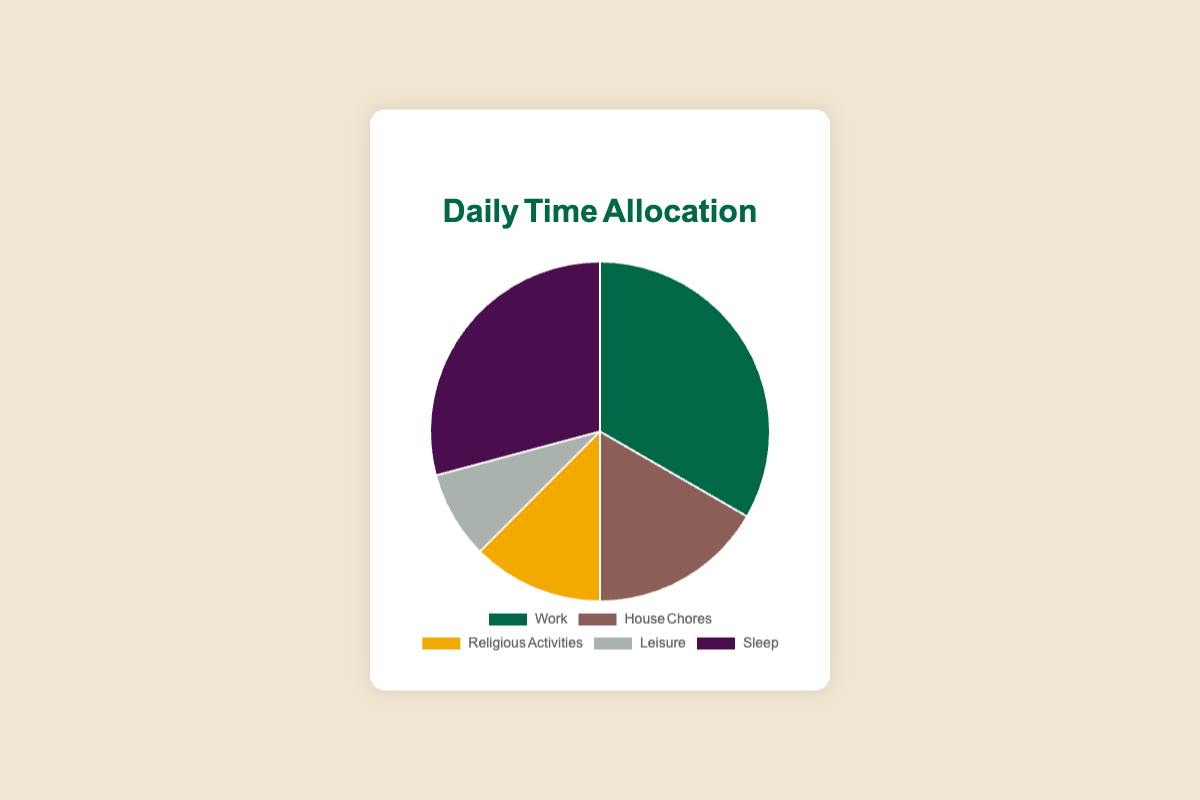What is the total amount of time spent on Work and Sleep combined? The time spent on Work is 8 hours and on Sleep is 7 hours. Adding them together: 8 + 7 = 15.
Answer: 15 hours Which activity has the longest duration? By looking at the pie chart, the activity with the longest duration is "Work" which has 8 hours.
Answer: Work Which activity has more hours allocated: House Chores or Leisure? By comparing the durations, House Chores has 4 hours and Leisure has 2 hours. House Chores has more allocated hours.
Answer: House Chores What is the difference in time allocation between the activity with the most hours and the activity with the least hours? The activity with the most hours is Work (8 hours). The one with the least is Leisure (2 hours). The difference is 8 - 2 = 6.
Answer: 6 hours How many more hours are spent on Religious Activities compared to Leisure? Religious Activities take 3 hours and Leisure takes 2 hours. The difference is 3 - 2 = 1.
Answer: 1 hour What is the total number of hours dedicated to activities other than Sleep? The total time excluding Sleep (7 hours) can be found by adding the hours of all other activities: Work (8) + House Chores (4) + Religious Activities (3) + Leisure (2) = 17.
Answer: 17 hours What percentage of the day is allocated to Religious Activities? The total hours in a day considered here is 24. Religious Activities take 3 hours. The percentage is calculated as (3/24) * 100 ≈ 12.5%.
Answer: ~12.5% How does the time spent on Leisure compare to the time spent on House Chores and Religious Activities combined? Leisure takes 2 hours. House Chores and Religious Activities combined is 4 + 3 = 7 hours. Leisure takes fewer hours.
Answer: Leisure is less What is the average time allocation for all activities excluding Sleep? Excluding Sleep (7 hours), the total count of activities is 4 and their combined hours are 8 (Work) + 4 (House Chores) + 3 (Religious Activities) + 2 (Leisure) = 17. The average is 17/4 = 4.25 hours.
Answer: 4.25 hours 